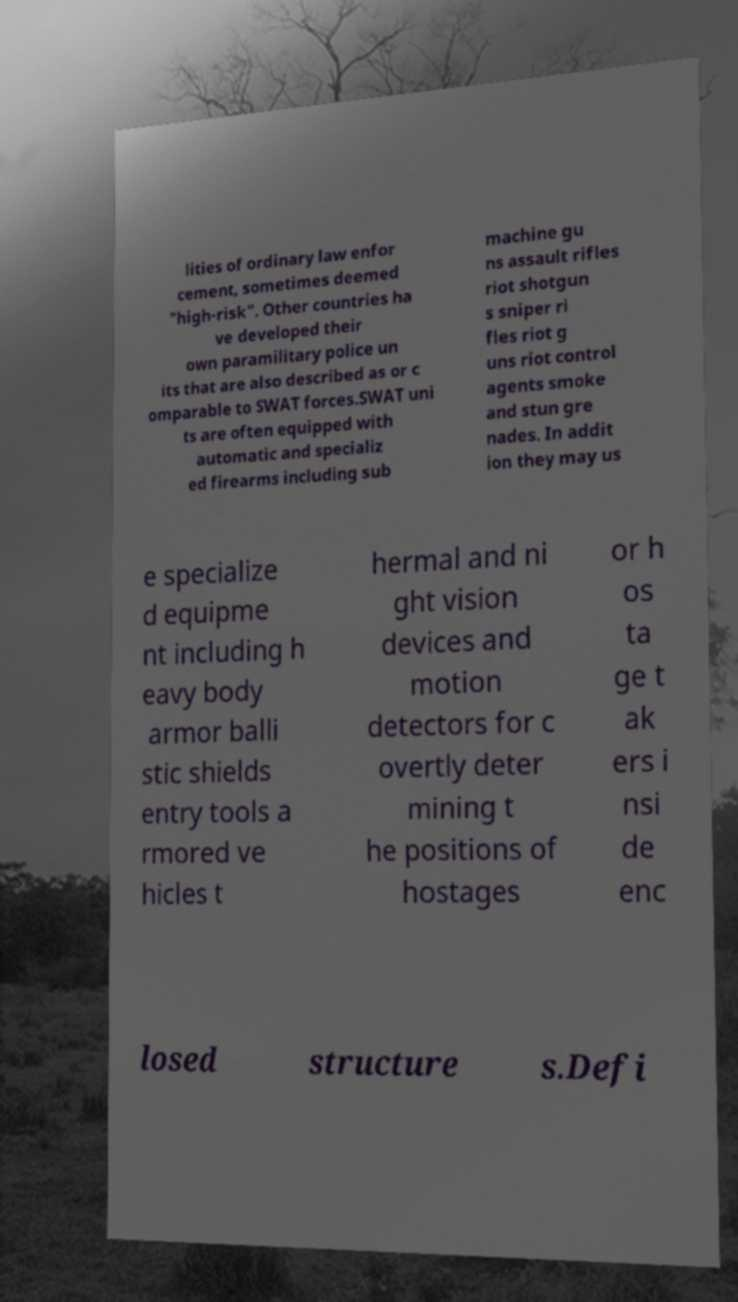Could you extract and type out the text from this image? lities of ordinary law enfor cement, sometimes deemed "high-risk". Other countries ha ve developed their own paramilitary police un its that are also described as or c omparable to SWAT forces.SWAT uni ts are often equipped with automatic and specializ ed firearms including sub machine gu ns assault rifles riot shotgun s sniper ri fles riot g uns riot control agents smoke and stun gre nades. In addit ion they may us e specialize d equipme nt including h eavy body armor balli stic shields entry tools a rmored ve hicles t hermal and ni ght vision devices and motion detectors for c overtly deter mining t he positions of hostages or h os ta ge t ak ers i nsi de enc losed structure s.Defi 